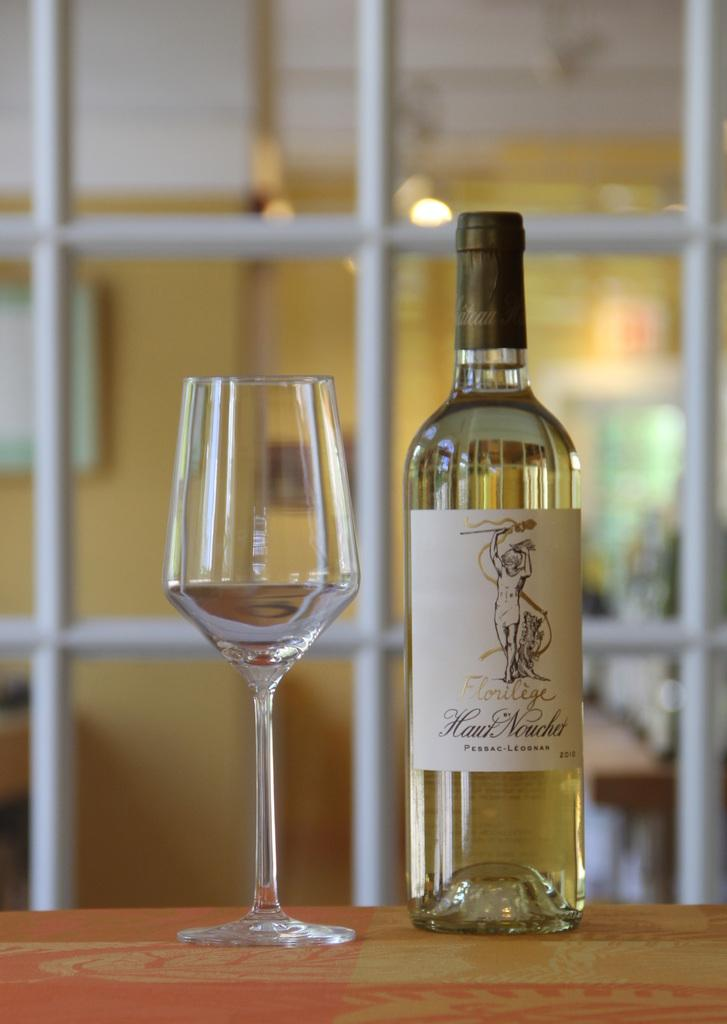What is inside the bottle that has a label in the image? The bottle contains a drink. What is placed beside the bottle in the image? There is a glass beside the bottle. Where are the bottle and glass located in the image? The bottle and glass are placed on a table. What color are the toes of the person in the image? There is no person present in the image, so we cannot determine the color of their toes. 